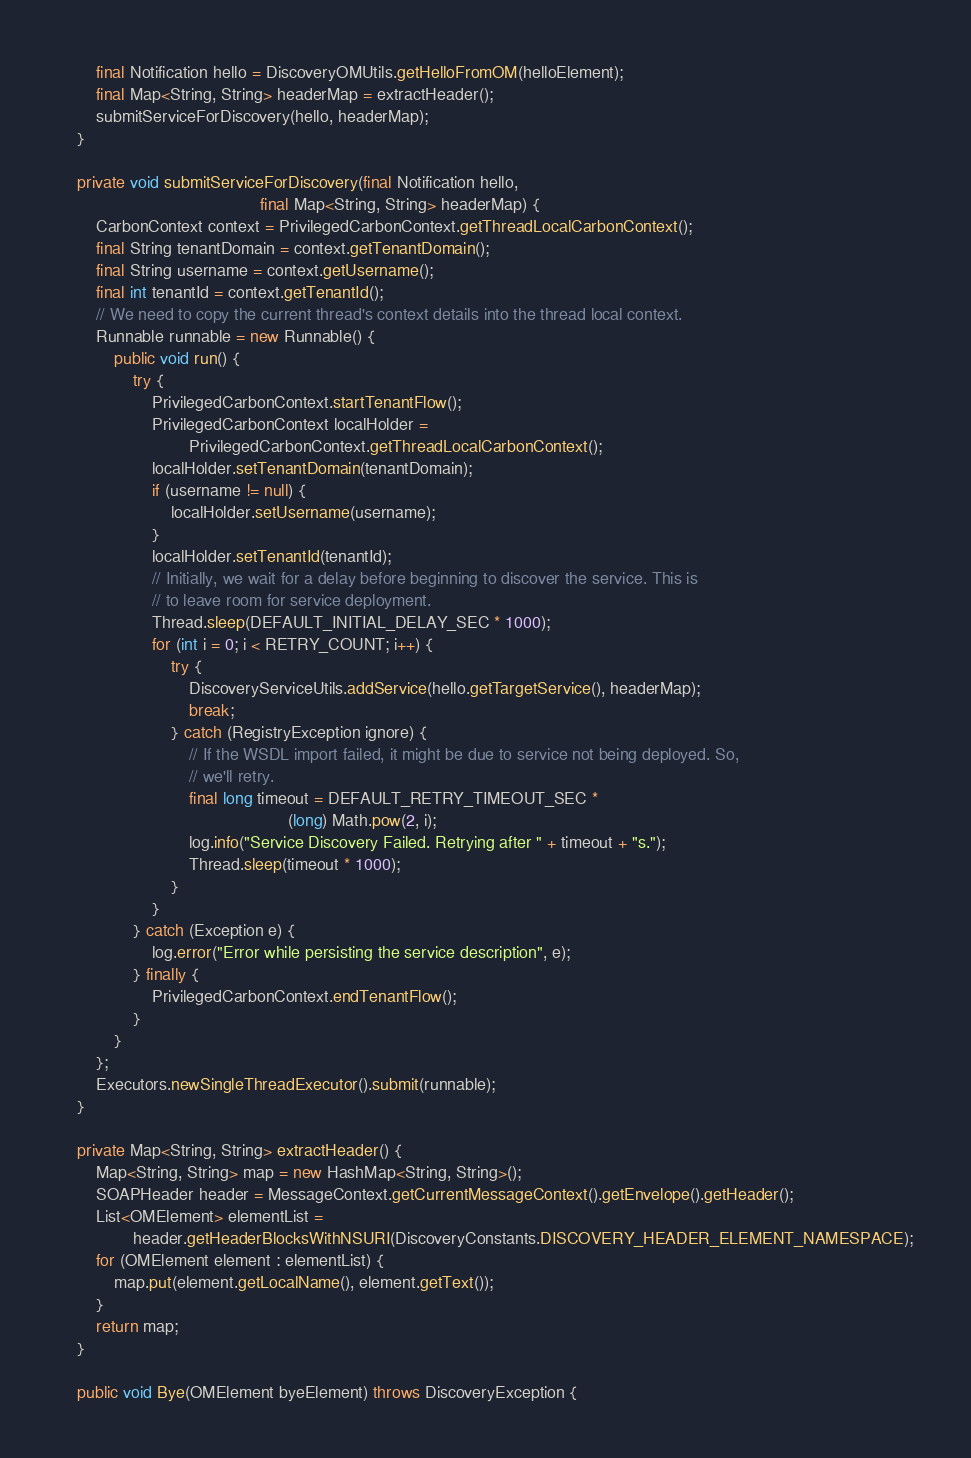<code> <loc_0><loc_0><loc_500><loc_500><_Java_>        final Notification hello = DiscoveryOMUtils.getHelloFromOM(helloElement);
        final Map<String, String> headerMap = extractHeader();
        submitServiceForDiscovery(hello, headerMap);
    }

    private void submitServiceForDiscovery(final Notification hello,
                                           final Map<String, String> headerMap) {
        CarbonContext context = PrivilegedCarbonContext.getThreadLocalCarbonContext();
        final String tenantDomain = context.getTenantDomain();
        final String username = context.getUsername();
        final int tenantId = context.getTenantId();
        // We need to copy the current thread's context details into the thread local context.
        Runnable runnable = new Runnable() {
            public void run() {
                try {
                    PrivilegedCarbonContext.startTenantFlow();
                    PrivilegedCarbonContext localHolder =
                            PrivilegedCarbonContext.getThreadLocalCarbonContext();
                    localHolder.setTenantDomain(tenantDomain);
                    if (username != null) {
                        localHolder.setUsername(username);
                    }
                    localHolder.setTenantId(tenantId);
                    // Initially, we wait for a delay before beginning to discover the service. This is
                    // to leave room for service deployment.
                    Thread.sleep(DEFAULT_INITIAL_DELAY_SEC * 1000);
                    for (int i = 0; i < RETRY_COUNT; i++) {
                        try {
                            DiscoveryServiceUtils.addService(hello.getTargetService(), headerMap);
                            break;
                        } catch (RegistryException ignore) {
                            // If the WSDL import failed, it might be due to service not being deployed. So,
                            // we'll retry.
                            final long timeout = DEFAULT_RETRY_TIMEOUT_SEC *
                                                 (long) Math.pow(2, i);
                            log.info("Service Discovery Failed. Retrying after " + timeout + "s.");
                            Thread.sleep(timeout * 1000);
                        }
                    }
                } catch (Exception e) {
                    log.error("Error while persisting the service description", e);
                } finally {
                    PrivilegedCarbonContext.endTenantFlow();
                }
            }
        };
        Executors.newSingleThreadExecutor().submit(runnable);
    }

    private Map<String, String> extractHeader() {
        Map<String, String> map = new HashMap<String, String>();
        SOAPHeader header = MessageContext.getCurrentMessageContext().getEnvelope().getHeader();
        List<OMElement> elementList =
                header.getHeaderBlocksWithNSURI(DiscoveryConstants.DISCOVERY_HEADER_ELEMENT_NAMESPACE);
        for (OMElement element : elementList) {
            map.put(element.getLocalName(), element.getText());
        }
        return map;
    }

    public void Bye(OMElement byeElement) throws DiscoveryException {</code> 